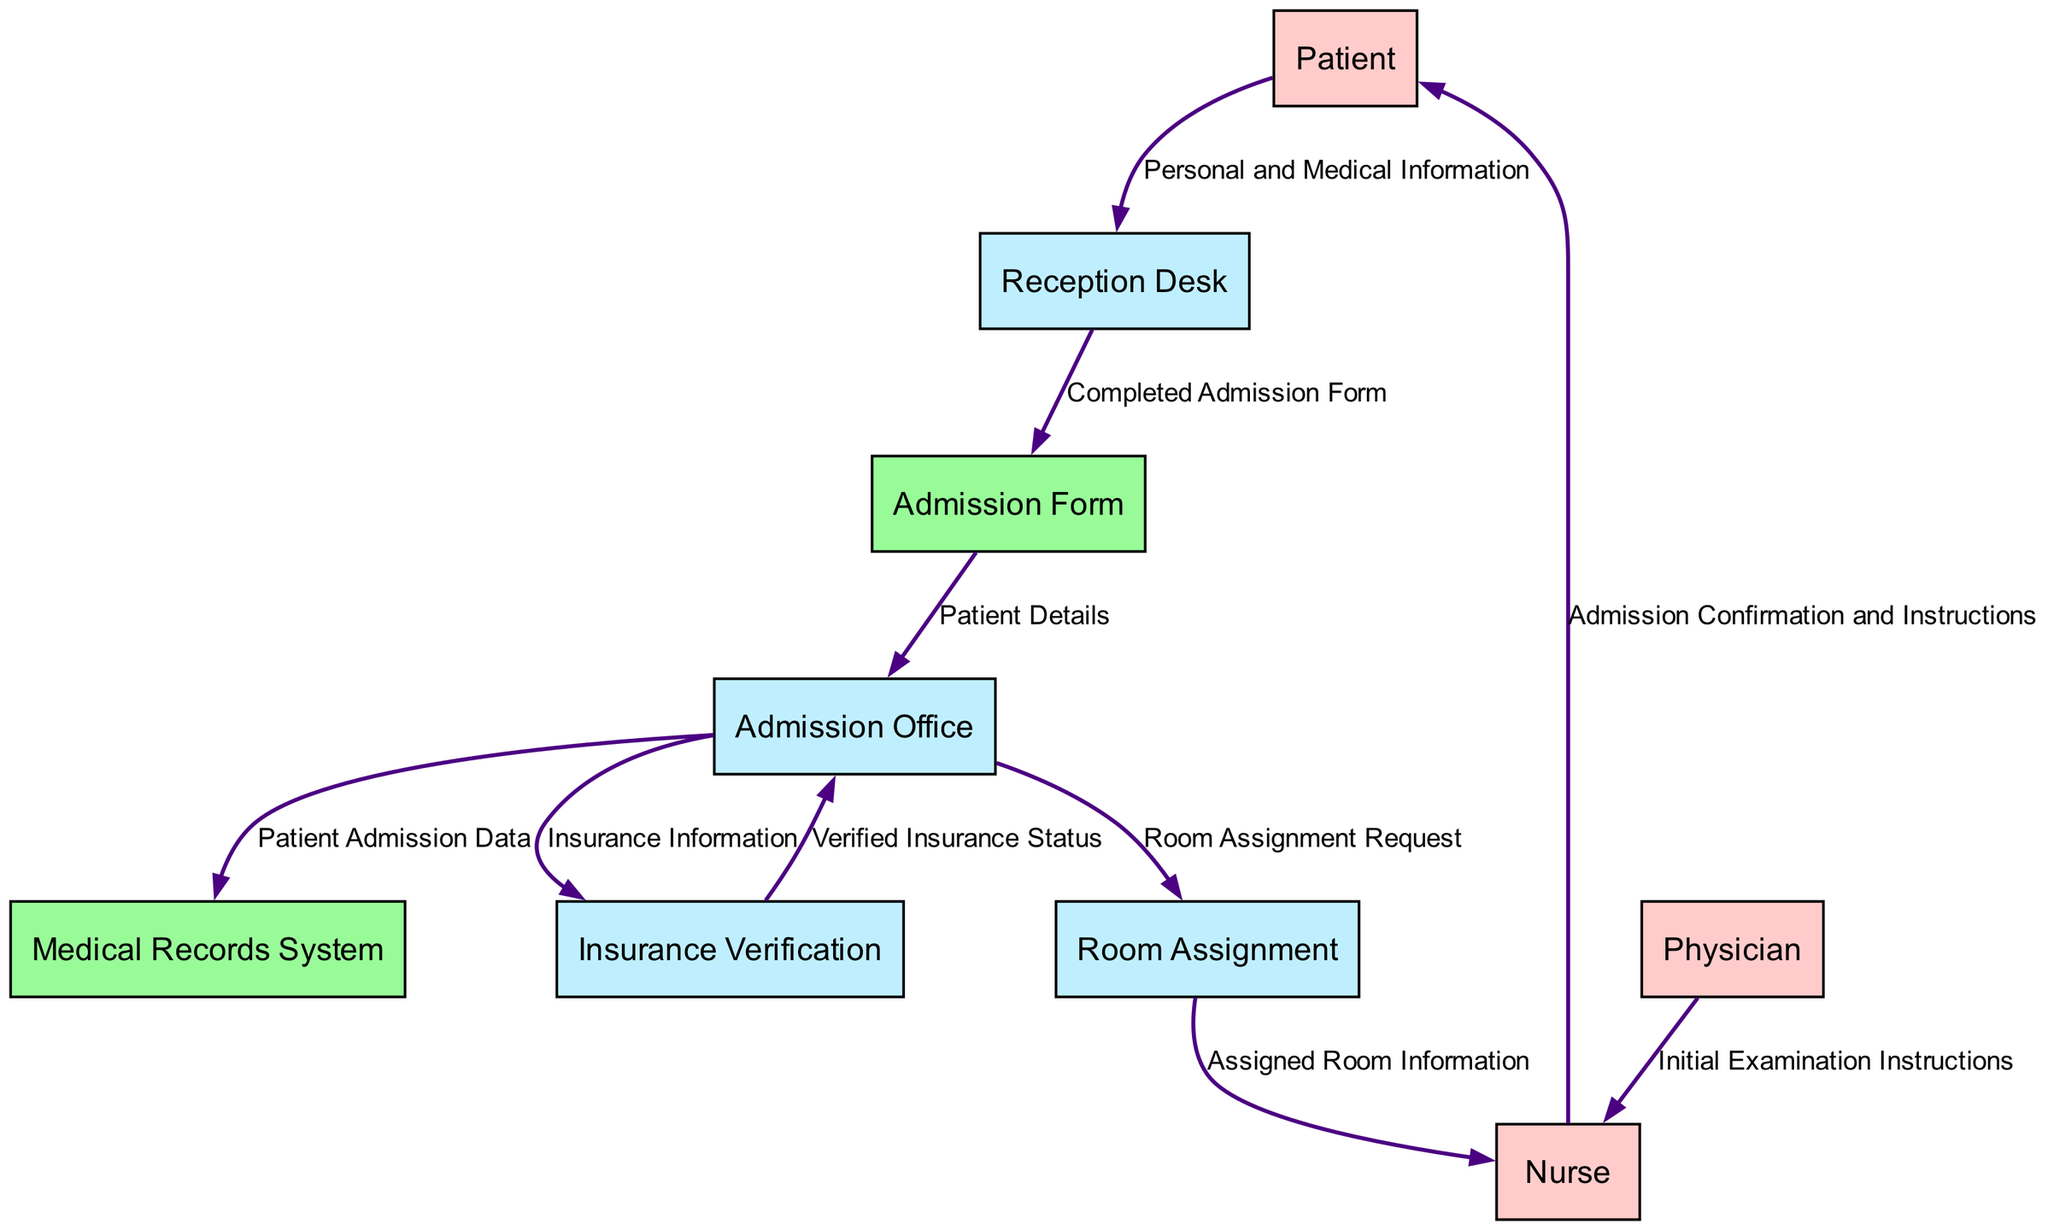How many processes are in the diagram? The diagram lists five processes: Reception Desk, Admission Office, Insurance Verification, Room Assignment, and Nurse. Counting these processes gives a total of five.
Answer: five What is the source of the data flow to the Admission Form? The Admission Form receives data from the Reception Desk, which provides the Completed Admission Form. This relationship is indicated by the flow line connecting these nodes.
Answer: Reception Desk Which external entity provides Personal and Medical Information? The Patient is the external entity that supplies Personal and Medical Information to the Reception Desk as part of the admission process. This is shown by the directed data flow arrow going from Patient to Reception Desk.
Answer: Patient Which process sends the Assigned Room Information to the Nurse? The Room Assignment process is responsible for sending the Assigned Room Information to the Nurse, as illustrated by the data flow from Room Assignment to Nurse.
Answer: Room Assignment What data does the Nurse provide to the Patient? The Nurse provides Admission Confirmation and Instructions to the Patient, completing the admission communication. This flow is directed from Nurse to Patient in the diagram.
Answer: Admission Confirmation and Instructions What is the final data flow action after the Admission Office? After the Admission Office processes the Patient Admission Data, it sends it to the Medical Records System and proceeds with a Room Assignment Request. This indicates a branching action where two flows lead out from the Admission Office.
Answer: Medical Records System and Room Assignment Request How many external entities are included in the diagram? There are three external entities in the diagram: Patient, Nurse, and Physician. Counting these gives a total of three external entities that interact in the patient admission process.
Answer: three What is the role of the Insurance Verification process? The Insurance Verification process is responsible for verifying the Insurance Information received from the Admission Office. It sends back the Verified Insurance Status to the Admission Office, indicating it plays a crucial role in confirming coverage.
Answer: verifying insurance status Which external entity interacts with the Nurse besides the Patient? The Physician is the external entity that also interacts with the Nurse, providing Initial Examination Instructions. This relationship is depicted by the data flow from Physician to Nurse, indicating another layer of interaction in the process.
Answer: Physician 